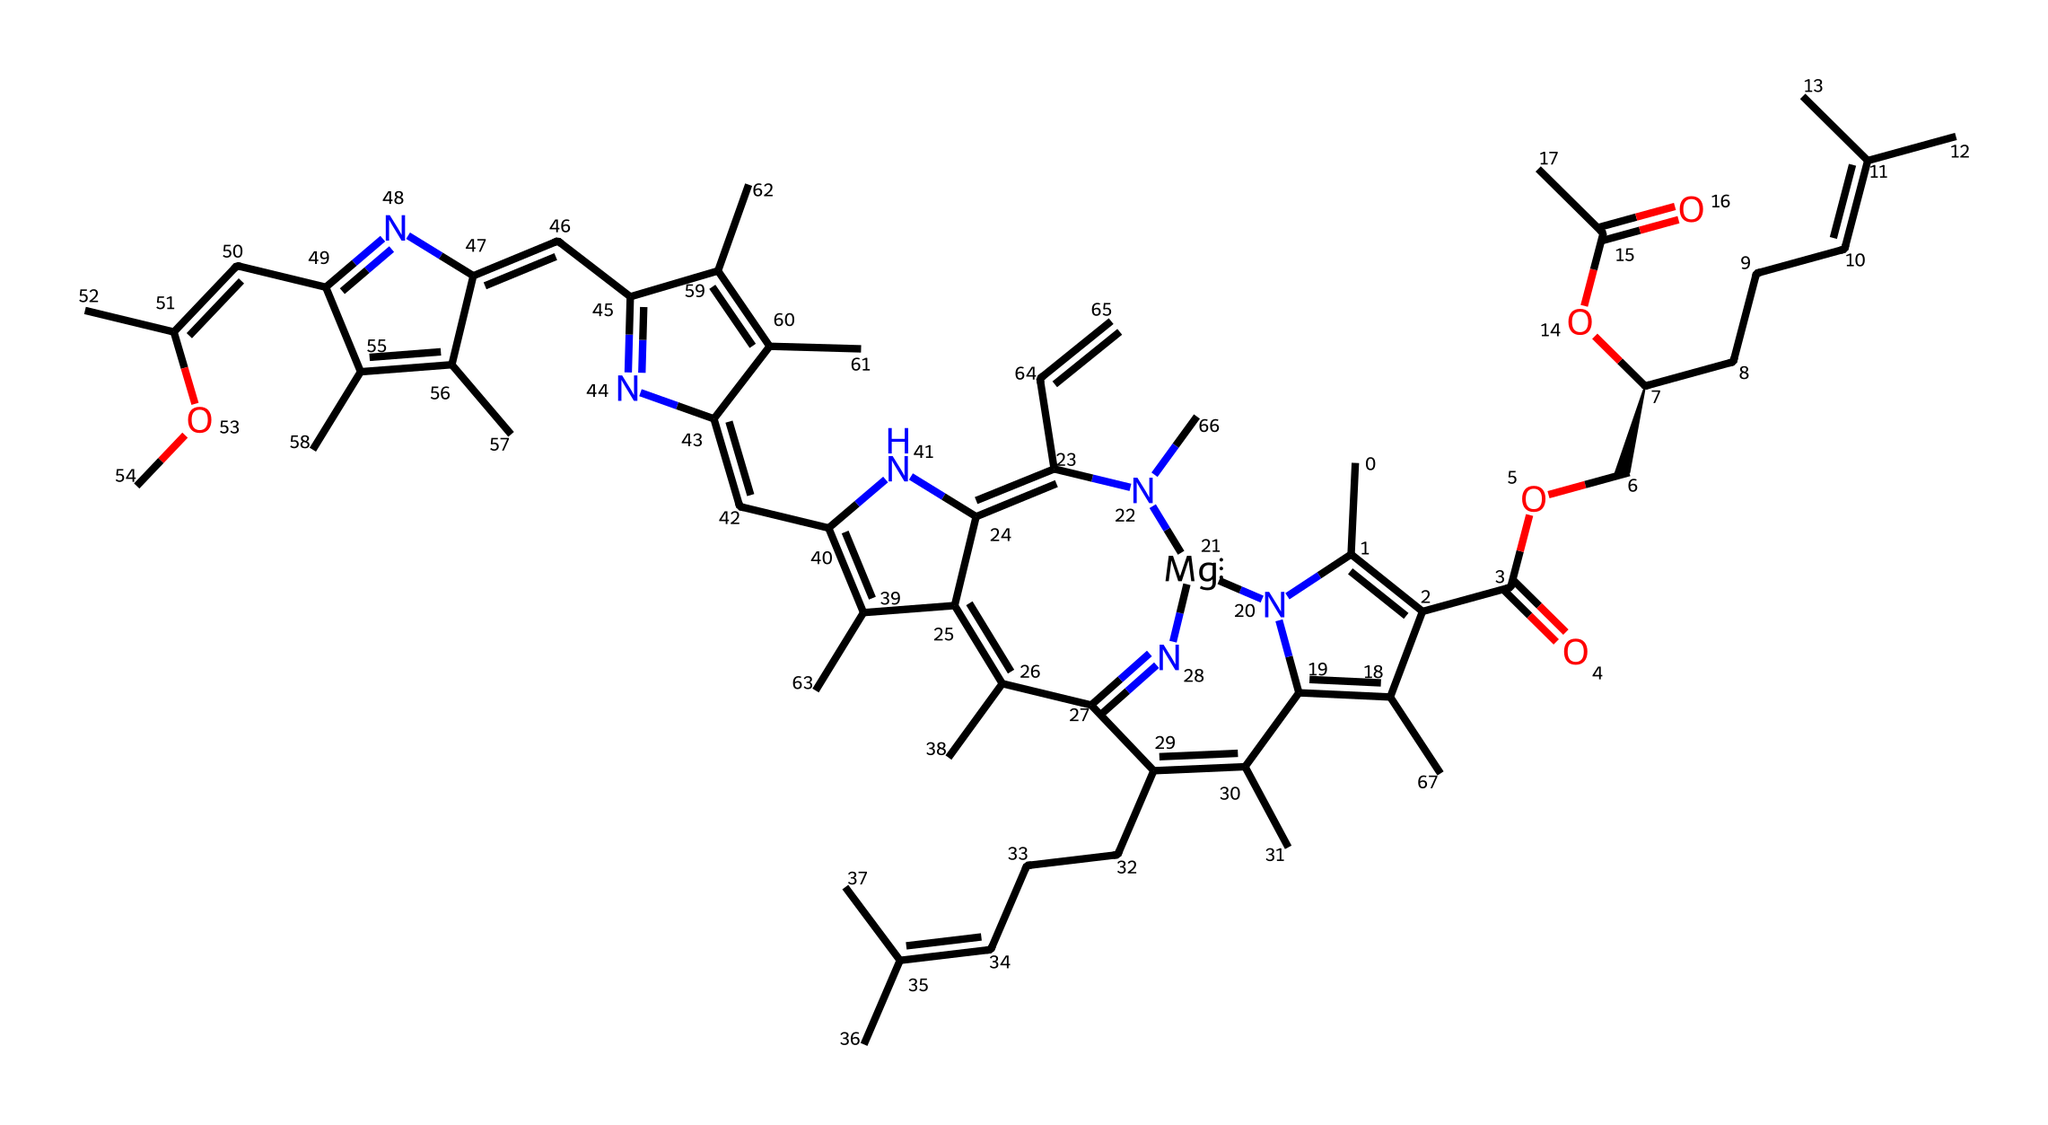What is the central metal atom in chlorophyll? The structure contains a magnesium atom, which is evident as it is specifically noted in the SMILES representation. Chlorophyll is known to have magnesium at its center, coordinating with surrounding atoms.
Answer: magnesium How many nitrogen atoms are present in the chlorophyll structure? By carefully examining the SMILES and counting the 'N' characters, we can identify there are four nitrogen atoms present in the structure of chlorophyll.
Answer: 4 What type of coordination compound is chlorophyll classified as? Chlorophyll is classified as a metal coordination compound due to its complex formed around a central metal atom, magnesium, with various ligands surrounding it.
Answer: metal coordination compound How many carbon atoms are included in the chlorophyll structure? Counting the 'C' characters in the SMILES representation reveals there are 21 carbon atoms in the structure of chlorophyll, indicating its complex organic framework.
Answer: 21 What functional groups are indicated in the chlorophyll structure? The structure contains ester functional groups, as recognized by the 'OC' patterns in the SMILES, which denotes the presence of esters due to the carboxylic acid derivatives linked to the carbon backbone.
Answer: esters What is the role of the magnesium atom in chlorophyll? Magnesium plays a crucial role as a central atom in chlorophyll, facilitating electron transfer in the process of photosynthesis. This coordination is vital for capturing light energy.
Answer: electron transfer 